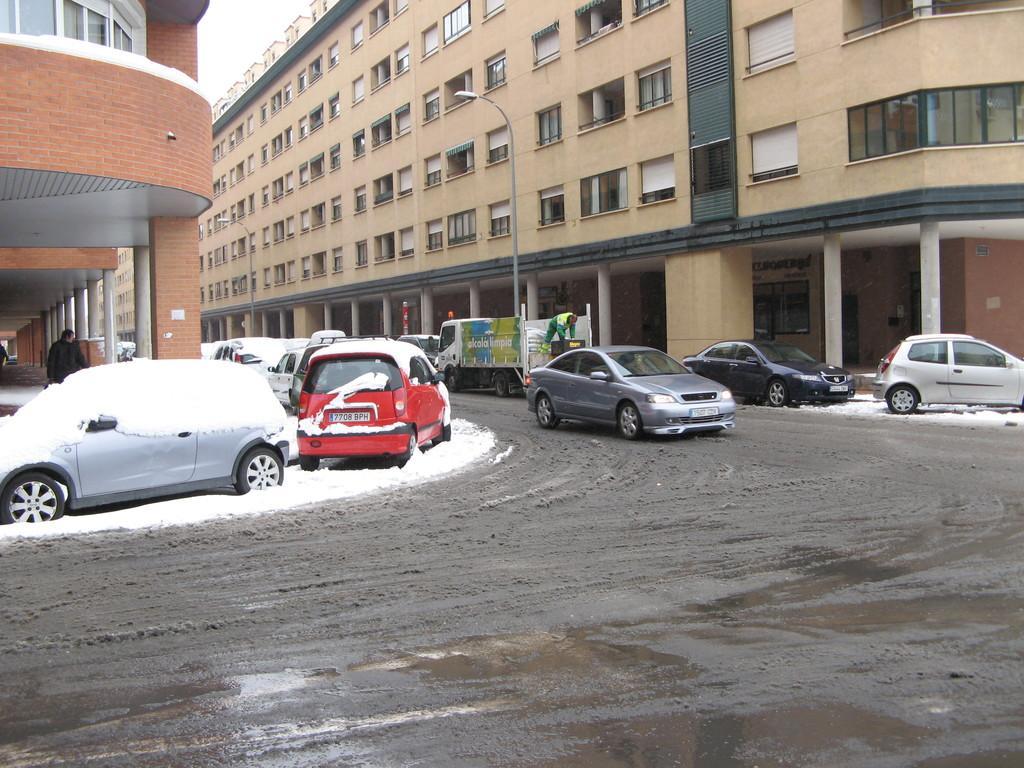Could you give a brief overview of what you see in this image? In the image there are few cars on the road with buildings on either side of it with many windows on it. 